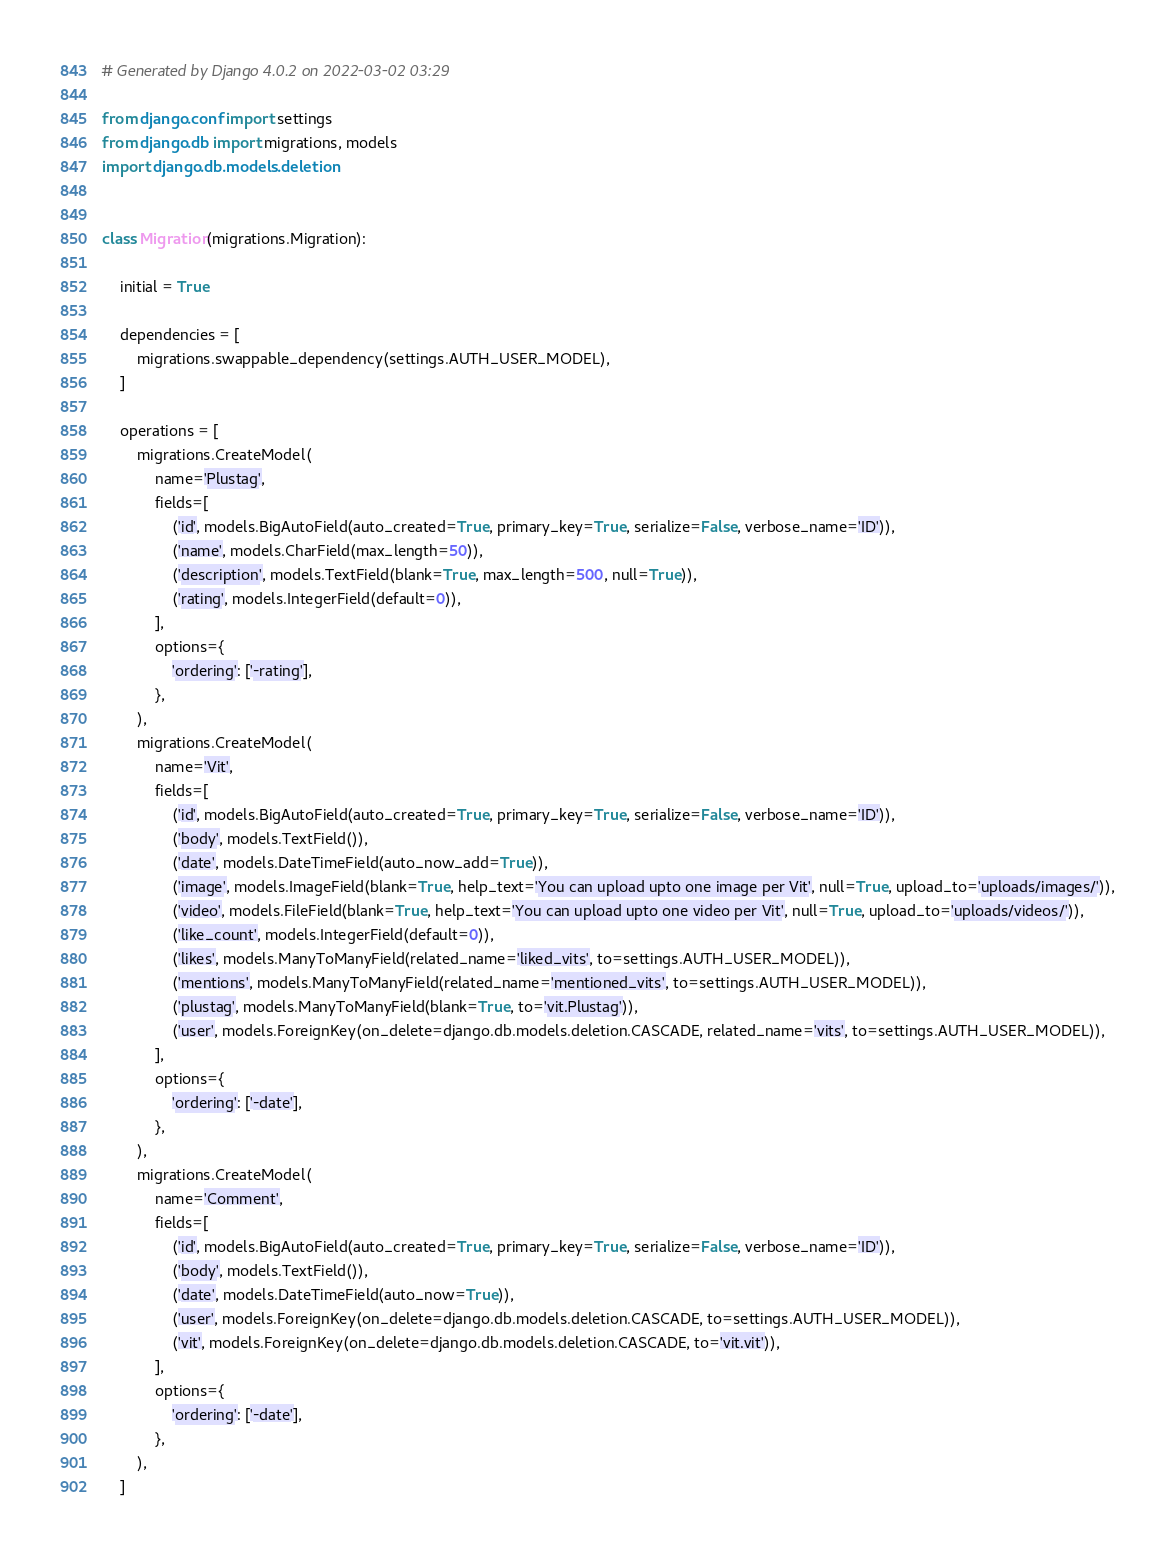Convert code to text. <code><loc_0><loc_0><loc_500><loc_500><_Python_># Generated by Django 4.0.2 on 2022-03-02 03:29

from django.conf import settings
from django.db import migrations, models
import django.db.models.deletion


class Migration(migrations.Migration):

    initial = True

    dependencies = [
        migrations.swappable_dependency(settings.AUTH_USER_MODEL),
    ]

    operations = [
        migrations.CreateModel(
            name='Plustag',
            fields=[
                ('id', models.BigAutoField(auto_created=True, primary_key=True, serialize=False, verbose_name='ID')),
                ('name', models.CharField(max_length=50)),
                ('description', models.TextField(blank=True, max_length=500, null=True)),
                ('rating', models.IntegerField(default=0)),
            ],
            options={
                'ordering': ['-rating'],
            },
        ),
        migrations.CreateModel(
            name='Vit',
            fields=[
                ('id', models.BigAutoField(auto_created=True, primary_key=True, serialize=False, verbose_name='ID')),
                ('body', models.TextField()),
                ('date', models.DateTimeField(auto_now_add=True)),
                ('image', models.ImageField(blank=True, help_text='You can upload upto one image per Vit', null=True, upload_to='uploads/images/')),
                ('video', models.FileField(blank=True, help_text='You can upload upto one video per Vit', null=True, upload_to='uploads/videos/')),
                ('like_count', models.IntegerField(default=0)),
                ('likes', models.ManyToManyField(related_name='liked_vits', to=settings.AUTH_USER_MODEL)),
                ('mentions', models.ManyToManyField(related_name='mentioned_vits', to=settings.AUTH_USER_MODEL)),
                ('plustag', models.ManyToManyField(blank=True, to='vit.Plustag')),
                ('user', models.ForeignKey(on_delete=django.db.models.deletion.CASCADE, related_name='vits', to=settings.AUTH_USER_MODEL)),
            ],
            options={
                'ordering': ['-date'],
            },
        ),
        migrations.CreateModel(
            name='Comment',
            fields=[
                ('id', models.BigAutoField(auto_created=True, primary_key=True, serialize=False, verbose_name='ID')),
                ('body', models.TextField()),
                ('date', models.DateTimeField(auto_now=True)),
                ('user', models.ForeignKey(on_delete=django.db.models.deletion.CASCADE, to=settings.AUTH_USER_MODEL)),
                ('vit', models.ForeignKey(on_delete=django.db.models.deletion.CASCADE, to='vit.vit')),
            ],
            options={
                'ordering': ['-date'],
            },
        ),
    ]
</code> 